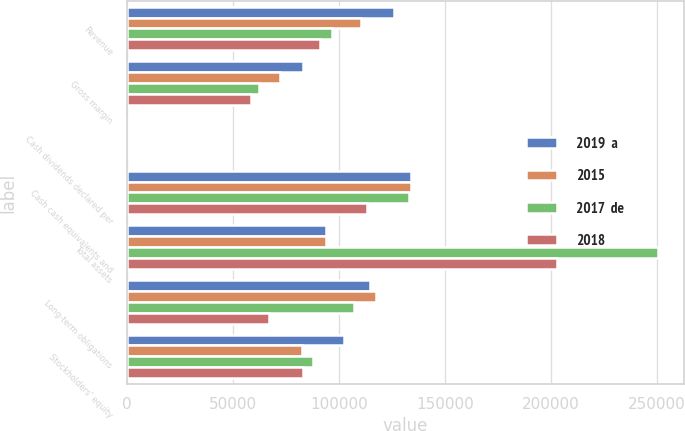Convert chart. <chart><loc_0><loc_0><loc_500><loc_500><stacked_bar_chart><ecel><fcel>Revenue<fcel>Gross margin<fcel>Cash dividends declared per<fcel>Cash cash equivalents and<fcel>Total assets<fcel>Long-term obligations<fcel>Stockholders' equity<nl><fcel>2019  a<fcel>125843<fcel>82933<fcel>1.84<fcel>133819<fcel>93862.5<fcel>114806<fcel>102330<nl><fcel>2015<fcel>110360<fcel>72007<fcel>1.68<fcel>133768<fcel>93862.5<fcel>117642<fcel>82718<nl><fcel>2017  de<fcel>96571<fcel>62310<fcel>1.56<fcel>132981<fcel>250312<fcel>106856<fcel>87711<nl><fcel>2018<fcel>91154<fcel>58374<fcel>1.44<fcel>113240<fcel>202897<fcel>66705<fcel>83090<nl></chart> 